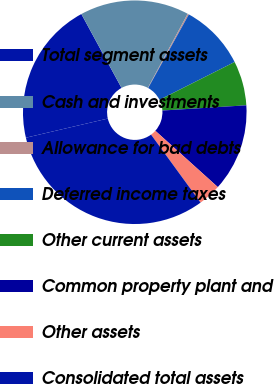Convert chart to OTSL. <chart><loc_0><loc_0><loc_500><loc_500><pie_chart><fcel>Total segment assets<fcel>Cash and investments<fcel>Allowance for bad debts<fcel>Deferred income taxes<fcel>Other current assets<fcel>Common property plant and<fcel>Other assets<fcel>Consolidated total assets<nl><fcel>20.73%<fcel>15.78%<fcel>0.19%<fcel>9.54%<fcel>6.43%<fcel>12.66%<fcel>3.31%<fcel>31.36%<nl></chart> 